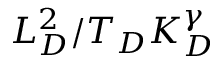Convert formula to latex. <formula><loc_0><loc_0><loc_500><loc_500>L _ { D } ^ { 2 } / T _ { D } K _ { D } ^ { \gamma }</formula> 